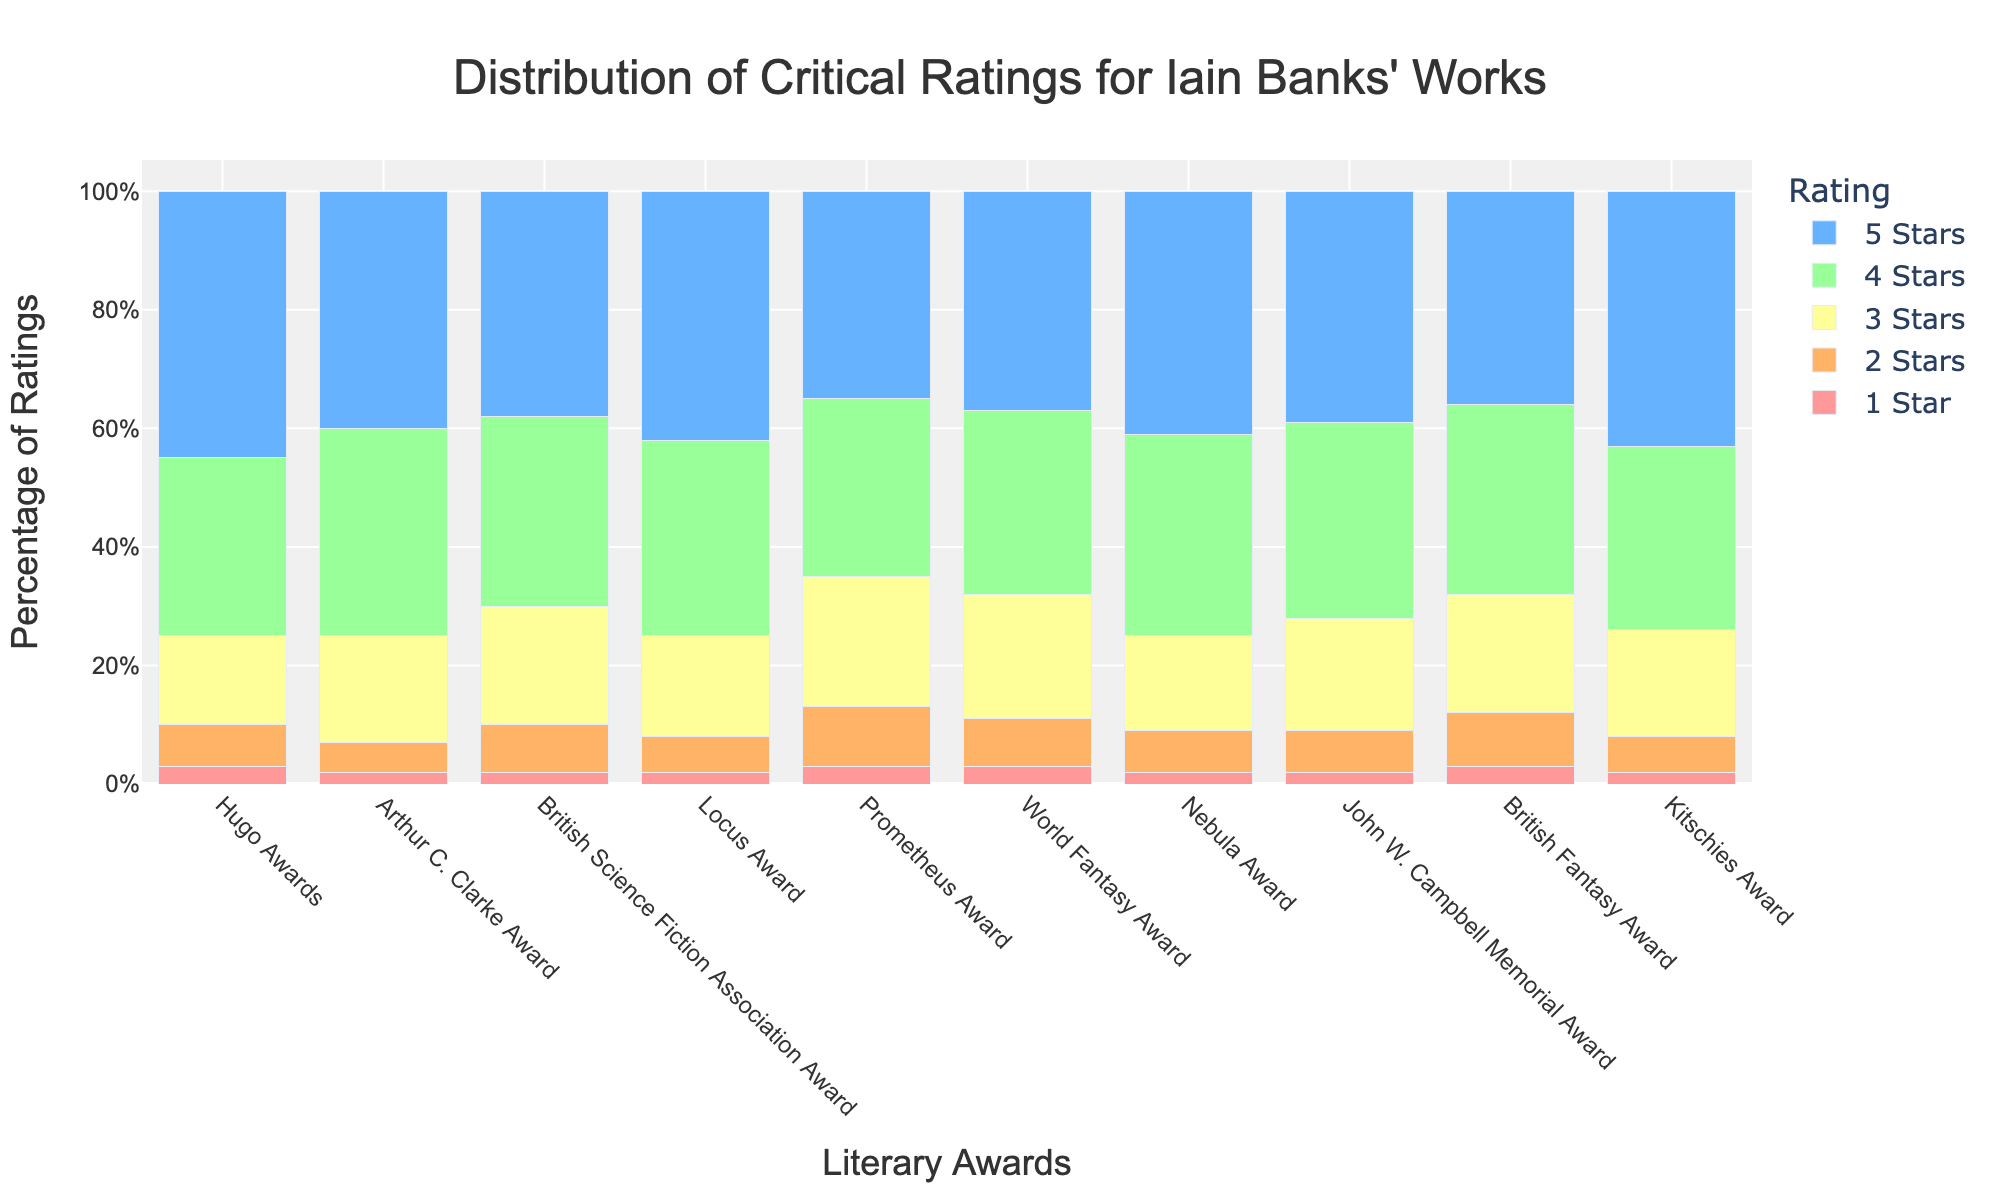Which award has the highest number of 5-star ratings? Look at the height of the bars colored red (representing 5-star ratings) across all awards and identify the highest bar. The Hugo Awards have the tallest red bar, indicating the highest number of 5-star ratings.
Answer: Hugo Awards Which award has the lowest number of 1-star ratings? Look at the height of the bars colored blue (representing 1-star ratings) across all awards and identify the shortest bar. Both the Arthur C. Clarke Award, British Science Fiction Association Award, Locus Award, Nebula Award, John W. Campbell Memorial Award, and Kitschies Award have the shortest blue bars.
Answer: Arthur C. Clarke Award, British Science Fiction Association Award, Locus Award, Nebula Award, John W. Campbell Memorial Award, Kitschies Award How does the number of 3-star ratings for the Prometheus Award compare to the British Science Fiction Association Award? Compare the height of the yellow bars (representing 3-star ratings) for the Prometheus Award and the British Science Fiction Association Award. The yellow bar for the Prometheus Award is taller than the one for the British Science Fiction Association Award.
Answer: More Which award has a nearly equal distribution of 4-star and 3-star ratings? Identify the awards where the height of the orange bars (4 stars) and yellow bars (3 stars) are close in height. For the Prometheus Award, the orange and yellow bars are nearly equal.
Answer: Prometheus Award What percentage of the total ratings for the Hugo Awards are 5-star ratings? Calculate the total ratings by summing the counts of all star ratings for the Hugo Awards and then divide the number of 5-star ratings by this total. Multiply by 100 to get the percentage. Total ratings for Hugo Awards = 45 + 30 + 15 + 7 + 3 = 100. Percentage of 5-star ratings = (45/100) * 100 = 45%.
Answer: 45% Among the given awards, which one has the greatest difference between 5-star and 1-star ratings? Subtract the number of 1-star ratings from the number of 5-star ratings for each award and identify the largest difference. The Hugo Awards have the largest difference: 45 - 3 = 42.
Answer: Hugo Awards Which award has the second highest number of 4-star ratings? Look at the height of the orange bars (representing 4-star ratings) and identify the one that is the second tallest. The Arthur C. Clarke Award has the highest number of 4-star ratings, followed by the Nebula Award.
Answer: Nebula Award What is the total number of ratings given for the World Fantasy Award? Sum the counts of all star ratings for the World Fantasy Award. Total ratings = 37 + 31 + 21 + 8 + 3 = 100.
Answer: 100 How does the distribution of ratings for the Locus Award differ visually from the British Fantasy Award? Compare the bars for both awards. Both have similar distributions, but the Locus Award tends to have slightly more 5-star and 4-star ratings while the British Fantasy Award has slightly more 2-star and 3-star ratings.
Answer: Locus has more high ratings (5, 4-stars); British Fantasy has more low ratings (2, 3-stars) Which rating category shows the least variability across all awards? Look at the bars for each rating category across all awards. The 1-star rating (blue bars) is the category with the least variability, as all the blue bars are fairly short and similar in height.
Answer: 1-star rating 